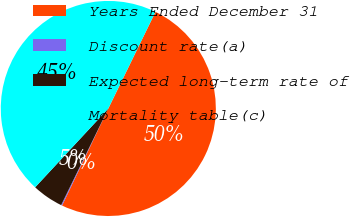Convert chart to OTSL. <chart><loc_0><loc_0><loc_500><loc_500><pie_chart><fcel>Years Ended December 31<fcel>Discount rate(a)<fcel>Expected long-term rate of<fcel>Mortality table(c)<nl><fcel>49.85%<fcel>0.15%<fcel>4.68%<fcel>45.32%<nl></chart> 